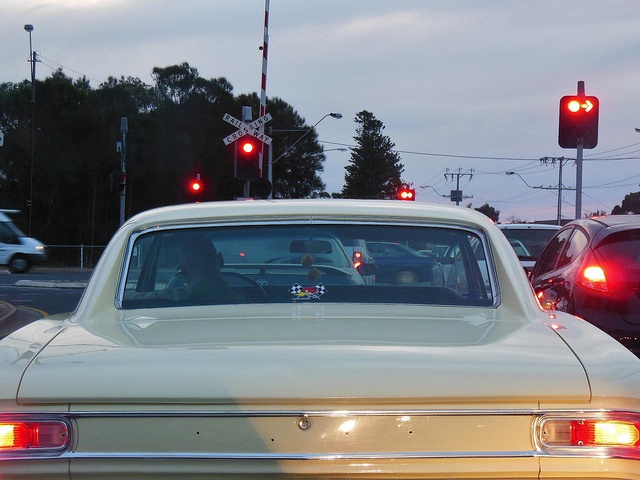Describe the objects in this image and their specific colors. I can see car in lightgray, darkgray, gray, darkblue, and tan tones, car in lightgray, black, maroon, darkgray, and purple tones, people in lightgray, darkblue, blue, and navy tones, car in lightgray, black, gray, and blue tones, and traffic light in lightgray, black, maroon, red, and brown tones in this image. 